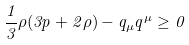Convert formula to latex. <formula><loc_0><loc_0><loc_500><loc_500>\frac { 1 } { 3 } \rho ( 3 p + 2 \rho ) - q _ { \mu } q ^ { \mu } \geq 0</formula> 